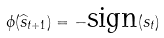<formula> <loc_0><loc_0><loc_500><loc_500>\phi ( \widehat { s } _ { t + 1 } ) = - \text {sign} ( s _ { t } )</formula> 